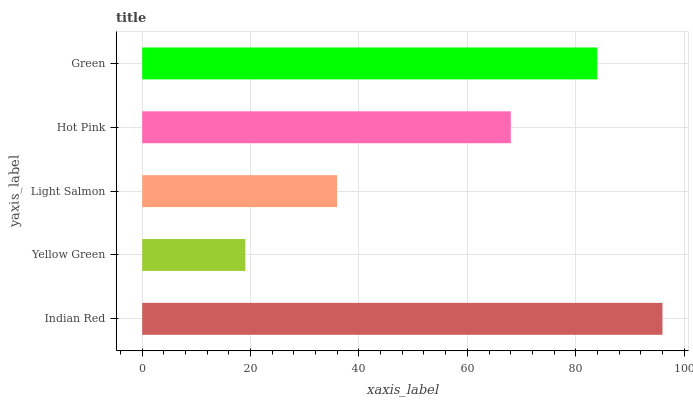Is Yellow Green the minimum?
Answer yes or no. Yes. Is Indian Red the maximum?
Answer yes or no. Yes. Is Light Salmon the minimum?
Answer yes or no. No. Is Light Salmon the maximum?
Answer yes or no. No. Is Light Salmon greater than Yellow Green?
Answer yes or no. Yes. Is Yellow Green less than Light Salmon?
Answer yes or no. Yes. Is Yellow Green greater than Light Salmon?
Answer yes or no. No. Is Light Salmon less than Yellow Green?
Answer yes or no. No. Is Hot Pink the high median?
Answer yes or no. Yes. Is Hot Pink the low median?
Answer yes or no. Yes. Is Green the high median?
Answer yes or no. No. Is Light Salmon the low median?
Answer yes or no. No. 